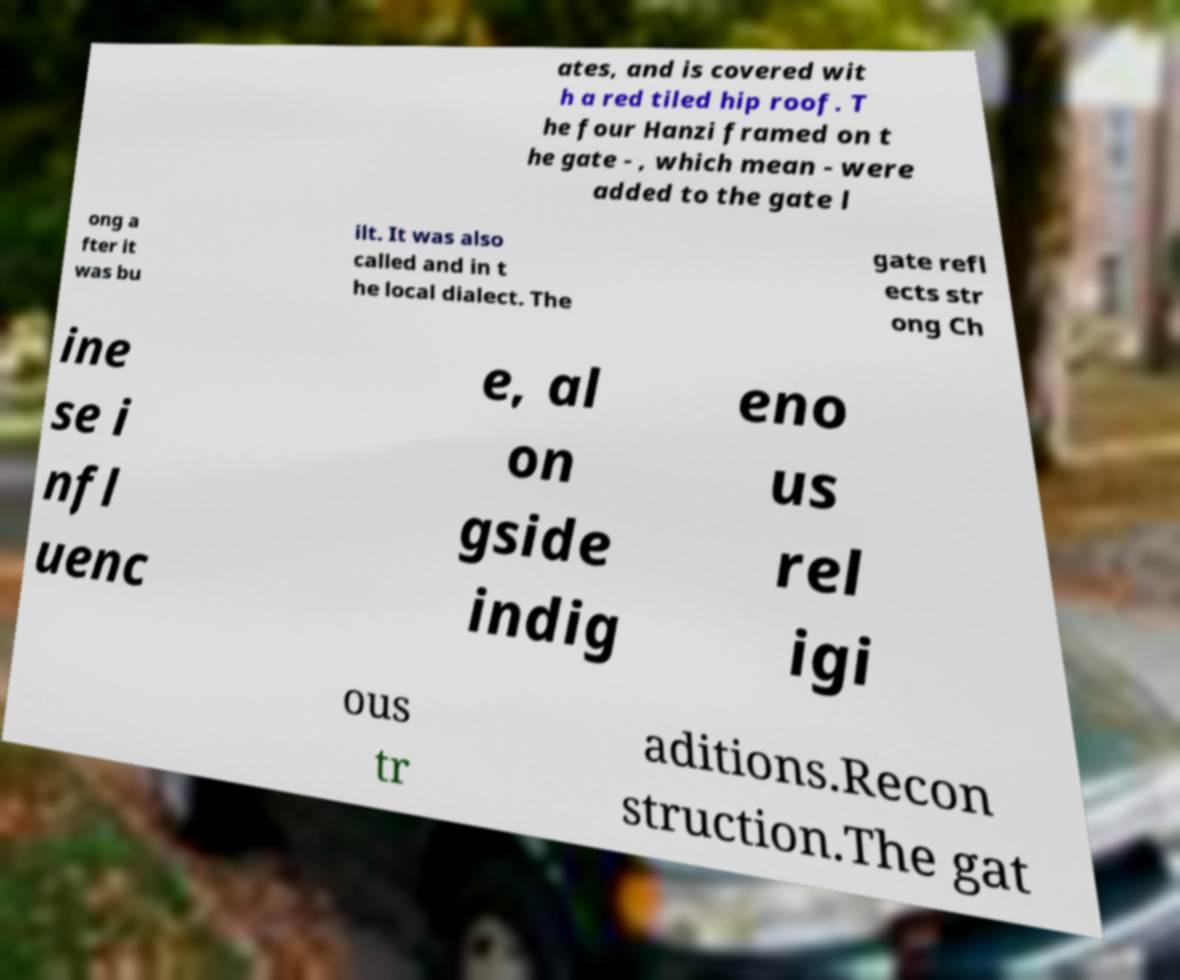What messages or text are displayed in this image? I need them in a readable, typed format. ates, and is covered wit h a red tiled hip roof. T he four Hanzi framed on t he gate - , which mean - were added to the gate l ong a fter it was bu ilt. It was also called and in t he local dialect. The gate refl ects str ong Ch ine se i nfl uenc e, al on gside indig eno us rel igi ous tr aditions.Recon struction.The gat 